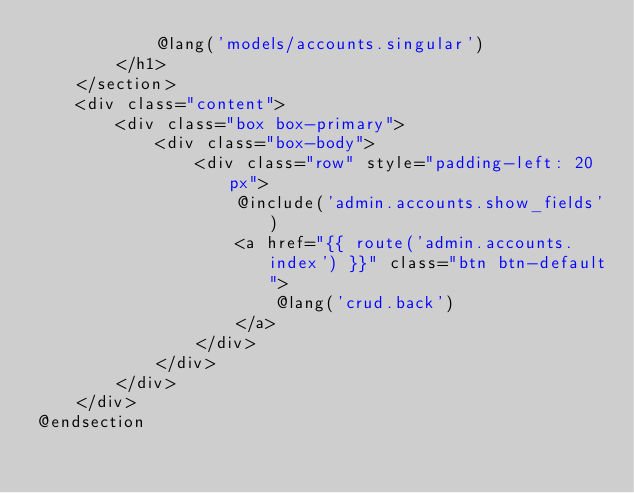<code> <loc_0><loc_0><loc_500><loc_500><_PHP_>            @lang('models/accounts.singular')
        </h1>
    </section>
    <div class="content">
        <div class="box box-primary">
            <div class="box-body">
                <div class="row" style="padding-left: 20px">
                    @include('admin.accounts.show_fields')
                    <a href="{{ route('admin.accounts.index') }}" class="btn btn-default">
                        @lang('crud.back')
                    </a>
                </div>
            </div>
        </div>
    </div>
@endsection
</code> 